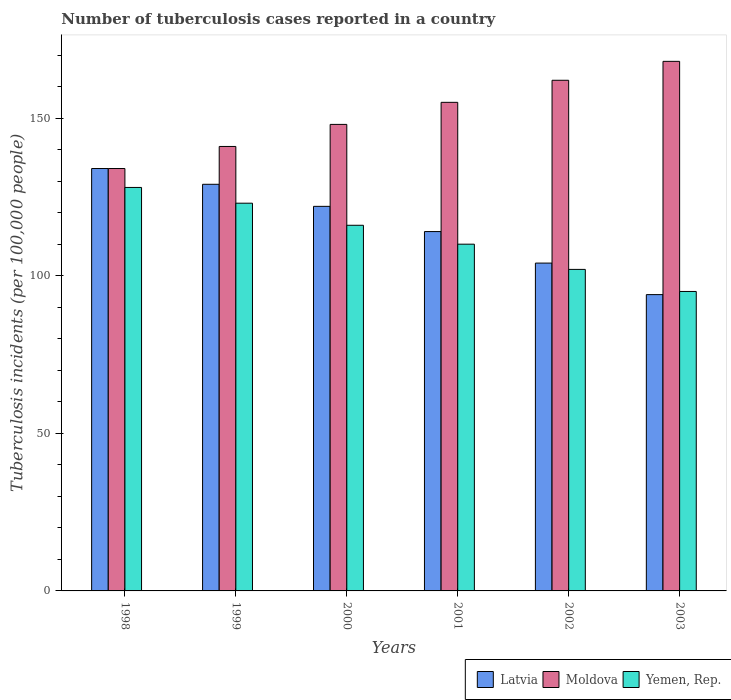Are the number of bars on each tick of the X-axis equal?
Your response must be concise. Yes. What is the number of tuberculosis cases reported in in Yemen, Rep. in 2002?
Your response must be concise. 102. Across all years, what is the maximum number of tuberculosis cases reported in in Latvia?
Your answer should be compact. 134. Across all years, what is the minimum number of tuberculosis cases reported in in Moldova?
Your answer should be compact. 134. In which year was the number of tuberculosis cases reported in in Yemen, Rep. minimum?
Your answer should be compact. 2003. What is the total number of tuberculosis cases reported in in Yemen, Rep. in the graph?
Offer a terse response. 674. What is the difference between the number of tuberculosis cases reported in in Latvia in 1998 and that in 1999?
Give a very brief answer. 5. What is the difference between the number of tuberculosis cases reported in in Moldova in 2001 and the number of tuberculosis cases reported in in Latvia in 1999?
Keep it short and to the point. 26. What is the average number of tuberculosis cases reported in in Yemen, Rep. per year?
Provide a succinct answer. 112.33. In the year 1998, what is the difference between the number of tuberculosis cases reported in in Yemen, Rep. and number of tuberculosis cases reported in in Latvia?
Keep it short and to the point. -6. In how many years, is the number of tuberculosis cases reported in in Moldova greater than 70?
Make the answer very short. 6. What is the ratio of the number of tuberculosis cases reported in in Moldova in 2002 to that in 2003?
Your answer should be very brief. 0.96. What is the difference between the highest and the second highest number of tuberculosis cases reported in in Latvia?
Ensure brevity in your answer.  5. What is the difference between the highest and the lowest number of tuberculosis cases reported in in Yemen, Rep.?
Keep it short and to the point. 33. In how many years, is the number of tuberculosis cases reported in in Moldova greater than the average number of tuberculosis cases reported in in Moldova taken over all years?
Your response must be concise. 3. Is the sum of the number of tuberculosis cases reported in in Moldova in 2001 and 2002 greater than the maximum number of tuberculosis cases reported in in Yemen, Rep. across all years?
Your answer should be compact. Yes. What does the 3rd bar from the left in 1999 represents?
Offer a terse response. Yemen, Rep. What does the 2nd bar from the right in 1999 represents?
Make the answer very short. Moldova. How many years are there in the graph?
Make the answer very short. 6. What is the difference between two consecutive major ticks on the Y-axis?
Offer a very short reply. 50. Does the graph contain grids?
Make the answer very short. No. Where does the legend appear in the graph?
Make the answer very short. Bottom right. How many legend labels are there?
Make the answer very short. 3. What is the title of the graph?
Keep it short and to the point. Number of tuberculosis cases reported in a country. Does "Mauritius" appear as one of the legend labels in the graph?
Ensure brevity in your answer.  No. What is the label or title of the X-axis?
Provide a succinct answer. Years. What is the label or title of the Y-axis?
Provide a short and direct response. Tuberculosis incidents (per 100,0 people). What is the Tuberculosis incidents (per 100,000 people) of Latvia in 1998?
Ensure brevity in your answer.  134. What is the Tuberculosis incidents (per 100,000 people) of Moldova in 1998?
Provide a short and direct response. 134. What is the Tuberculosis incidents (per 100,000 people) of Yemen, Rep. in 1998?
Provide a short and direct response. 128. What is the Tuberculosis incidents (per 100,000 people) of Latvia in 1999?
Your response must be concise. 129. What is the Tuberculosis incidents (per 100,000 people) in Moldova in 1999?
Make the answer very short. 141. What is the Tuberculosis incidents (per 100,000 people) in Yemen, Rep. in 1999?
Offer a terse response. 123. What is the Tuberculosis incidents (per 100,000 people) of Latvia in 2000?
Provide a succinct answer. 122. What is the Tuberculosis incidents (per 100,000 people) of Moldova in 2000?
Keep it short and to the point. 148. What is the Tuberculosis incidents (per 100,000 people) in Yemen, Rep. in 2000?
Provide a succinct answer. 116. What is the Tuberculosis incidents (per 100,000 people) in Latvia in 2001?
Offer a very short reply. 114. What is the Tuberculosis incidents (per 100,000 people) of Moldova in 2001?
Provide a short and direct response. 155. What is the Tuberculosis incidents (per 100,000 people) of Yemen, Rep. in 2001?
Provide a succinct answer. 110. What is the Tuberculosis incidents (per 100,000 people) in Latvia in 2002?
Ensure brevity in your answer.  104. What is the Tuberculosis incidents (per 100,000 people) of Moldova in 2002?
Keep it short and to the point. 162. What is the Tuberculosis incidents (per 100,000 people) of Yemen, Rep. in 2002?
Provide a short and direct response. 102. What is the Tuberculosis incidents (per 100,000 people) in Latvia in 2003?
Ensure brevity in your answer.  94. What is the Tuberculosis incidents (per 100,000 people) of Moldova in 2003?
Ensure brevity in your answer.  168. What is the Tuberculosis incidents (per 100,000 people) of Yemen, Rep. in 2003?
Your response must be concise. 95. Across all years, what is the maximum Tuberculosis incidents (per 100,000 people) of Latvia?
Provide a succinct answer. 134. Across all years, what is the maximum Tuberculosis incidents (per 100,000 people) of Moldova?
Keep it short and to the point. 168. Across all years, what is the maximum Tuberculosis incidents (per 100,000 people) in Yemen, Rep.?
Offer a very short reply. 128. Across all years, what is the minimum Tuberculosis incidents (per 100,000 people) in Latvia?
Offer a very short reply. 94. Across all years, what is the minimum Tuberculosis incidents (per 100,000 people) of Moldova?
Give a very brief answer. 134. Across all years, what is the minimum Tuberculosis incidents (per 100,000 people) in Yemen, Rep.?
Provide a succinct answer. 95. What is the total Tuberculosis incidents (per 100,000 people) in Latvia in the graph?
Your answer should be compact. 697. What is the total Tuberculosis incidents (per 100,000 people) in Moldova in the graph?
Your answer should be very brief. 908. What is the total Tuberculosis incidents (per 100,000 people) in Yemen, Rep. in the graph?
Ensure brevity in your answer.  674. What is the difference between the Tuberculosis incidents (per 100,000 people) in Yemen, Rep. in 1998 and that in 1999?
Provide a short and direct response. 5. What is the difference between the Tuberculosis incidents (per 100,000 people) in Moldova in 1998 and that in 2000?
Offer a very short reply. -14. What is the difference between the Tuberculosis incidents (per 100,000 people) of Yemen, Rep. in 1998 and that in 2000?
Provide a succinct answer. 12. What is the difference between the Tuberculosis incidents (per 100,000 people) in Latvia in 1998 and that in 2001?
Make the answer very short. 20. What is the difference between the Tuberculosis incidents (per 100,000 people) in Yemen, Rep. in 1998 and that in 2001?
Offer a terse response. 18. What is the difference between the Tuberculosis incidents (per 100,000 people) of Latvia in 1998 and that in 2002?
Provide a short and direct response. 30. What is the difference between the Tuberculosis incidents (per 100,000 people) of Moldova in 1998 and that in 2002?
Your answer should be very brief. -28. What is the difference between the Tuberculosis incidents (per 100,000 people) of Latvia in 1998 and that in 2003?
Provide a short and direct response. 40. What is the difference between the Tuberculosis incidents (per 100,000 people) in Moldova in 1998 and that in 2003?
Offer a very short reply. -34. What is the difference between the Tuberculosis incidents (per 100,000 people) in Latvia in 1999 and that in 2000?
Offer a very short reply. 7. What is the difference between the Tuberculosis incidents (per 100,000 people) in Moldova in 1999 and that in 2000?
Keep it short and to the point. -7. What is the difference between the Tuberculosis incidents (per 100,000 people) in Yemen, Rep. in 1999 and that in 2000?
Provide a succinct answer. 7. What is the difference between the Tuberculosis incidents (per 100,000 people) in Latvia in 1999 and that in 2002?
Offer a terse response. 25. What is the difference between the Tuberculosis incidents (per 100,000 people) of Moldova in 2000 and that in 2001?
Give a very brief answer. -7. What is the difference between the Tuberculosis incidents (per 100,000 people) of Yemen, Rep. in 2000 and that in 2001?
Your response must be concise. 6. What is the difference between the Tuberculosis incidents (per 100,000 people) in Yemen, Rep. in 2000 and that in 2002?
Your response must be concise. 14. What is the difference between the Tuberculosis incidents (per 100,000 people) in Latvia in 2000 and that in 2003?
Your response must be concise. 28. What is the difference between the Tuberculosis incidents (per 100,000 people) in Yemen, Rep. in 2000 and that in 2003?
Ensure brevity in your answer.  21. What is the difference between the Tuberculosis incidents (per 100,000 people) in Latvia in 2001 and that in 2002?
Provide a succinct answer. 10. What is the difference between the Tuberculosis incidents (per 100,000 people) of Latvia in 2001 and that in 2003?
Make the answer very short. 20. What is the difference between the Tuberculosis incidents (per 100,000 people) in Latvia in 2002 and that in 2003?
Make the answer very short. 10. What is the difference between the Tuberculosis incidents (per 100,000 people) of Moldova in 2002 and that in 2003?
Make the answer very short. -6. What is the difference between the Tuberculosis incidents (per 100,000 people) in Latvia in 1998 and the Tuberculosis incidents (per 100,000 people) in Moldova in 1999?
Provide a short and direct response. -7. What is the difference between the Tuberculosis incidents (per 100,000 people) in Moldova in 1998 and the Tuberculosis incidents (per 100,000 people) in Yemen, Rep. in 1999?
Offer a very short reply. 11. What is the difference between the Tuberculosis incidents (per 100,000 people) in Latvia in 1998 and the Tuberculosis incidents (per 100,000 people) in Moldova in 2000?
Provide a succinct answer. -14. What is the difference between the Tuberculosis incidents (per 100,000 people) of Latvia in 1998 and the Tuberculosis incidents (per 100,000 people) of Moldova in 2001?
Keep it short and to the point. -21. What is the difference between the Tuberculosis incidents (per 100,000 people) of Moldova in 1998 and the Tuberculosis incidents (per 100,000 people) of Yemen, Rep. in 2001?
Give a very brief answer. 24. What is the difference between the Tuberculosis incidents (per 100,000 people) in Latvia in 1998 and the Tuberculosis incidents (per 100,000 people) in Moldova in 2002?
Give a very brief answer. -28. What is the difference between the Tuberculosis incidents (per 100,000 people) of Latvia in 1998 and the Tuberculosis incidents (per 100,000 people) of Moldova in 2003?
Offer a very short reply. -34. What is the difference between the Tuberculosis incidents (per 100,000 people) of Latvia in 1998 and the Tuberculosis incidents (per 100,000 people) of Yemen, Rep. in 2003?
Your answer should be compact. 39. What is the difference between the Tuberculosis incidents (per 100,000 people) of Latvia in 1999 and the Tuberculosis incidents (per 100,000 people) of Moldova in 2000?
Keep it short and to the point. -19. What is the difference between the Tuberculosis incidents (per 100,000 people) of Latvia in 1999 and the Tuberculosis incidents (per 100,000 people) of Yemen, Rep. in 2000?
Make the answer very short. 13. What is the difference between the Tuberculosis incidents (per 100,000 people) in Latvia in 1999 and the Tuberculosis incidents (per 100,000 people) in Moldova in 2001?
Give a very brief answer. -26. What is the difference between the Tuberculosis incidents (per 100,000 people) in Latvia in 1999 and the Tuberculosis incidents (per 100,000 people) in Moldova in 2002?
Offer a terse response. -33. What is the difference between the Tuberculosis incidents (per 100,000 people) of Latvia in 1999 and the Tuberculosis incidents (per 100,000 people) of Moldova in 2003?
Make the answer very short. -39. What is the difference between the Tuberculosis incidents (per 100,000 people) of Moldova in 1999 and the Tuberculosis incidents (per 100,000 people) of Yemen, Rep. in 2003?
Your answer should be compact. 46. What is the difference between the Tuberculosis incidents (per 100,000 people) of Latvia in 2000 and the Tuberculosis incidents (per 100,000 people) of Moldova in 2001?
Your response must be concise. -33. What is the difference between the Tuberculosis incidents (per 100,000 people) in Latvia in 2000 and the Tuberculosis incidents (per 100,000 people) in Yemen, Rep. in 2001?
Provide a short and direct response. 12. What is the difference between the Tuberculosis incidents (per 100,000 people) in Latvia in 2000 and the Tuberculosis incidents (per 100,000 people) in Moldova in 2002?
Keep it short and to the point. -40. What is the difference between the Tuberculosis incidents (per 100,000 people) of Latvia in 2000 and the Tuberculosis incidents (per 100,000 people) of Yemen, Rep. in 2002?
Offer a very short reply. 20. What is the difference between the Tuberculosis incidents (per 100,000 people) of Moldova in 2000 and the Tuberculosis incidents (per 100,000 people) of Yemen, Rep. in 2002?
Provide a succinct answer. 46. What is the difference between the Tuberculosis incidents (per 100,000 people) in Latvia in 2000 and the Tuberculosis incidents (per 100,000 people) in Moldova in 2003?
Make the answer very short. -46. What is the difference between the Tuberculosis incidents (per 100,000 people) of Latvia in 2000 and the Tuberculosis incidents (per 100,000 people) of Yemen, Rep. in 2003?
Offer a terse response. 27. What is the difference between the Tuberculosis incidents (per 100,000 people) of Latvia in 2001 and the Tuberculosis incidents (per 100,000 people) of Moldova in 2002?
Your response must be concise. -48. What is the difference between the Tuberculosis incidents (per 100,000 people) of Latvia in 2001 and the Tuberculosis incidents (per 100,000 people) of Yemen, Rep. in 2002?
Your answer should be compact. 12. What is the difference between the Tuberculosis incidents (per 100,000 people) in Moldova in 2001 and the Tuberculosis incidents (per 100,000 people) in Yemen, Rep. in 2002?
Make the answer very short. 53. What is the difference between the Tuberculosis incidents (per 100,000 people) of Latvia in 2001 and the Tuberculosis incidents (per 100,000 people) of Moldova in 2003?
Provide a short and direct response. -54. What is the difference between the Tuberculosis incidents (per 100,000 people) in Latvia in 2001 and the Tuberculosis incidents (per 100,000 people) in Yemen, Rep. in 2003?
Your answer should be very brief. 19. What is the difference between the Tuberculosis incidents (per 100,000 people) in Moldova in 2001 and the Tuberculosis incidents (per 100,000 people) in Yemen, Rep. in 2003?
Give a very brief answer. 60. What is the difference between the Tuberculosis incidents (per 100,000 people) in Latvia in 2002 and the Tuberculosis incidents (per 100,000 people) in Moldova in 2003?
Offer a terse response. -64. What is the difference between the Tuberculosis incidents (per 100,000 people) of Latvia in 2002 and the Tuberculosis incidents (per 100,000 people) of Yemen, Rep. in 2003?
Make the answer very short. 9. What is the difference between the Tuberculosis incidents (per 100,000 people) in Moldova in 2002 and the Tuberculosis incidents (per 100,000 people) in Yemen, Rep. in 2003?
Offer a terse response. 67. What is the average Tuberculosis incidents (per 100,000 people) in Latvia per year?
Your response must be concise. 116.17. What is the average Tuberculosis incidents (per 100,000 people) of Moldova per year?
Provide a short and direct response. 151.33. What is the average Tuberculosis incidents (per 100,000 people) in Yemen, Rep. per year?
Keep it short and to the point. 112.33. In the year 1998, what is the difference between the Tuberculosis incidents (per 100,000 people) in Latvia and Tuberculosis incidents (per 100,000 people) in Moldova?
Offer a terse response. 0. In the year 1999, what is the difference between the Tuberculosis incidents (per 100,000 people) in Latvia and Tuberculosis incidents (per 100,000 people) in Yemen, Rep.?
Your response must be concise. 6. In the year 1999, what is the difference between the Tuberculosis incidents (per 100,000 people) in Moldova and Tuberculosis incidents (per 100,000 people) in Yemen, Rep.?
Offer a very short reply. 18. In the year 2000, what is the difference between the Tuberculosis incidents (per 100,000 people) of Latvia and Tuberculosis incidents (per 100,000 people) of Yemen, Rep.?
Ensure brevity in your answer.  6. In the year 2001, what is the difference between the Tuberculosis incidents (per 100,000 people) of Latvia and Tuberculosis incidents (per 100,000 people) of Moldova?
Provide a succinct answer. -41. In the year 2001, what is the difference between the Tuberculosis incidents (per 100,000 people) in Latvia and Tuberculosis incidents (per 100,000 people) in Yemen, Rep.?
Provide a succinct answer. 4. In the year 2001, what is the difference between the Tuberculosis incidents (per 100,000 people) of Moldova and Tuberculosis incidents (per 100,000 people) of Yemen, Rep.?
Provide a succinct answer. 45. In the year 2002, what is the difference between the Tuberculosis incidents (per 100,000 people) in Latvia and Tuberculosis incidents (per 100,000 people) in Moldova?
Make the answer very short. -58. In the year 2002, what is the difference between the Tuberculosis incidents (per 100,000 people) in Moldova and Tuberculosis incidents (per 100,000 people) in Yemen, Rep.?
Provide a short and direct response. 60. In the year 2003, what is the difference between the Tuberculosis incidents (per 100,000 people) of Latvia and Tuberculosis incidents (per 100,000 people) of Moldova?
Keep it short and to the point. -74. In the year 2003, what is the difference between the Tuberculosis incidents (per 100,000 people) of Latvia and Tuberculosis incidents (per 100,000 people) of Yemen, Rep.?
Provide a succinct answer. -1. What is the ratio of the Tuberculosis incidents (per 100,000 people) in Latvia in 1998 to that in 1999?
Provide a succinct answer. 1.04. What is the ratio of the Tuberculosis incidents (per 100,000 people) in Moldova in 1998 to that in 1999?
Offer a very short reply. 0.95. What is the ratio of the Tuberculosis incidents (per 100,000 people) in Yemen, Rep. in 1998 to that in 1999?
Your answer should be very brief. 1.04. What is the ratio of the Tuberculosis incidents (per 100,000 people) of Latvia in 1998 to that in 2000?
Your answer should be very brief. 1.1. What is the ratio of the Tuberculosis incidents (per 100,000 people) in Moldova in 1998 to that in 2000?
Offer a very short reply. 0.91. What is the ratio of the Tuberculosis incidents (per 100,000 people) in Yemen, Rep. in 1998 to that in 2000?
Give a very brief answer. 1.1. What is the ratio of the Tuberculosis incidents (per 100,000 people) in Latvia in 1998 to that in 2001?
Offer a terse response. 1.18. What is the ratio of the Tuberculosis incidents (per 100,000 people) in Moldova in 1998 to that in 2001?
Your answer should be compact. 0.86. What is the ratio of the Tuberculosis incidents (per 100,000 people) of Yemen, Rep. in 1998 to that in 2001?
Offer a very short reply. 1.16. What is the ratio of the Tuberculosis incidents (per 100,000 people) of Latvia in 1998 to that in 2002?
Make the answer very short. 1.29. What is the ratio of the Tuberculosis incidents (per 100,000 people) of Moldova in 1998 to that in 2002?
Keep it short and to the point. 0.83. What is the ratio of the Tuberculosis incidents (per 100,000 people) of Yemen, Rep. in 1998 to that in 2002?
Provide a short and direct response. 1.25. What is the ratio of the Tuberculosis incidents (per 100,000 people) in Latvia in 1998 to that in 2003?
Your response must be concise. 1.43. What is the ratio of the Tuberculosis incidents (per 100,000 people) in Moldova in 1998 to that in 2003?
Provide a short and direct response. 0.8. What is the ratio of the Tuberculosis incidents (per 100,000 people) of Yemen, Rep. in 1998 to that in 2003?
Give a very brief answer. 1.35. What is the ratio of the Tuberculosis incidents (per 100,000 people) of Latvia in 1999 to that in 2000?
Ensure brevity in your answer.  1.06. What is the ratio of the Tuberculosis incidents (per 100,000 people) in Moldova in 1999 to that in 2000?
Keep it short and to the point. 0.95. What is the ratio of the Tuberculosis incidents (per 100,000 people) of Yemen, Rep. in 1999 to that in 2000?
Offer a terse response. 1.06. What is the ratio of the Tuberculosis incidents (per 100,000 people) in Latvia in 1999 to that in 2001?
Give a very brief answer. 1.13. What is the ratio of the Tuberculosis incidents (per 100,000 people) of Moldova in 1999 to that in 2001?
Offer a terse response. 0.91. What is the ratio of the Tuberculosis incidents (per 100,000 people) of Yemen, Rep. in 1999 to that in 2001?
Make the answer very short. 1.12. What is the ratio of the Tuberculosis incidents (per 100,000 people) in Latvia in 1999 to that in 2002?
Your answer should be very brief. 1.24. What is the ratio of the Tuberculosis incidents (per 100,000 people) of Moldova in 1999 to that in 2002?
Keep it short and to the point. 0.87. What is the ratio of the Tuberculosis incidents (per 100,000 people) of Yemen, Rep. in 1999 to that in 2002?
Your answer should be very brief. 1.21. What is the ratio of the Tuberculosis incidents (per 100,000 people) in Latvia in 1999 to that in 2003?
Ensure brevity in your answer.  1.37. What is the ratio of the Tuberculosis incidents (per 100,000 people) of Moldova in 1999 to that in 2003?
Offer a terse response. 0.84. What is the ratio of the Tuberculosis incidents (per 100,000 people) of Yemen, Rep. in 1999 to that in 2003?
Give a very brief answer. 1.29. What is the ratio of the Tuberculosis incidents (per 100,000 people) of Latvia in 2000 to that in 2001?
Give a very brief answer. 1.07. What is the ratio of the Tuberculosis incidents (per 100,000 people) of Moldova in 2000 to that in 2001?
Your answer should be very brief. 0.95. What is the ratio of the Tuberculosis incidents (per 100,000 people) of Yemen, Rep. in 2000 to that in 2001?
Make the answer very short. 1.05. What is the ratio of the Tuberculosis incidents (per 100,000 people) of Latvia in 2000 to that in 2002?
Provide a short and direct response. 1.17. What is the ratio of the Tuberculosis incidents (per 100,000 people) of Moldova in 2000 to that in 2002?
Offer a very short reply. 0.91. What is the ratio of the Tuberculosis incidents (per 100,000 people) of Yemen, Rep. in 2000 to that in 2002?
Your answer should be very brief. 1.14. What is the ratio of the Tuberculosis incidents (per 100,000 people) in Latvia in 2000 to that in 2003?
Provide a short and direct response. 1.3. What is the ratio of the Tuberculosis incidents (per 100,000 people) of Moldova in 2000 to that in 2003?
Keep it short and to the point. 0.88. What is the ratio of the Tuberculosis incidents (per 100,000 people) in Yemen, Rep. in 2000 to that in 2003?
Provide a succinct answer. 1.22. What is the ratio of the Tuberculosis incidents (per 100,000 people) of Latvia in 2001 to that in 2002?
Give a very brief answer. 1.1. What is the ratio of the Tuberculosis incidents (per 100,000 people) in Moldova in 2001 to that in 2002?
Your answer should be very brief. 0.96. What is the ratio of the Tuberculosis incidents (per 100,000 people) in Yemen, Rep. in 2001 to that in 2002?
Offer a terse response. 1.08. What is the ratio of the Tuberculosis incidents (per 100,000 people) of Latvia in 2001 to that in 2003?
Keep it short and to the point. 1.21. What is the ratio of the Tuberculosis incidents (per 100,000 people) of Moldova in 2001 to that in 2003?
Ensure brevity in your answer.  0.92. What is the ratio of the Tuberculosis incidents (per 100,000 people) of Yemen, Rep. in 2001 to that in 2003?
Your answer should be compact. 1.16. What is the ratio of the Tuberculosis incidents (per 100,000 people) of Latvia in 2002 to that in 2003?
Keep it short and to the point. 1.11. What is the ratio of the Tuberculosis incidents (per 100,000 people) of Moldova in 2002 to that in 2003?
Offer a very short reply. 0.96. What is the ratio of the Tuberculosis incidents (per 100,000 people) of Yemen, Rep. in 2002 to that in 2003?
Provide a succinct answer. 1.07. What is the difference between the highest and the second highest Tuberculosis incidents (per 100,000 people) in Latvia?
Provide a short and direct response. 5. What is the difference between the highest and the lowest Tuberculosis incidents (per 100,000 people) of Moldova?
Keep it short and to the point. 34. What is the difference between the highest and the lowest Tuberculosis incidents (per 100,000 people) in Yemen, Rep.?
Offer a terse response. 33. 